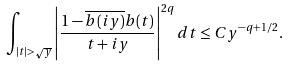<formula> <loc_0><loc_0><loc_500><loc_500>\int _ { | t | > \sqrt { y } } \left | \frac { 1 - \overline { b ( i y ) } b ( t ) } { t + i y } \right | ^ { 2 q } d t \leq C y ^ { - q + 1 / 2 } .</formula> 